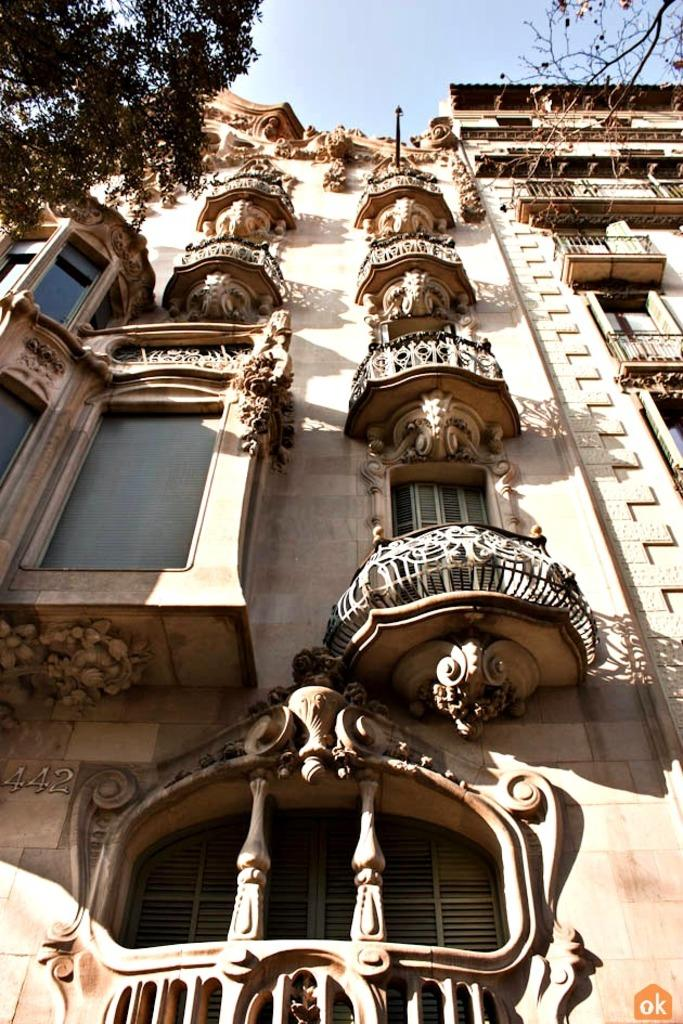What type of building is in the image? There is a heritage building in the image. What features can be seen on the heritage building? The heritage building has windows. What other elements are present in the image? There are trees in the image. What can be seen in the background of the image? The sky is visible in the background of the image. What advice is the heritage building giving to the trucks in the yard? There are no trucks or yards present in the image, and the heritage building is not giving any advice. 